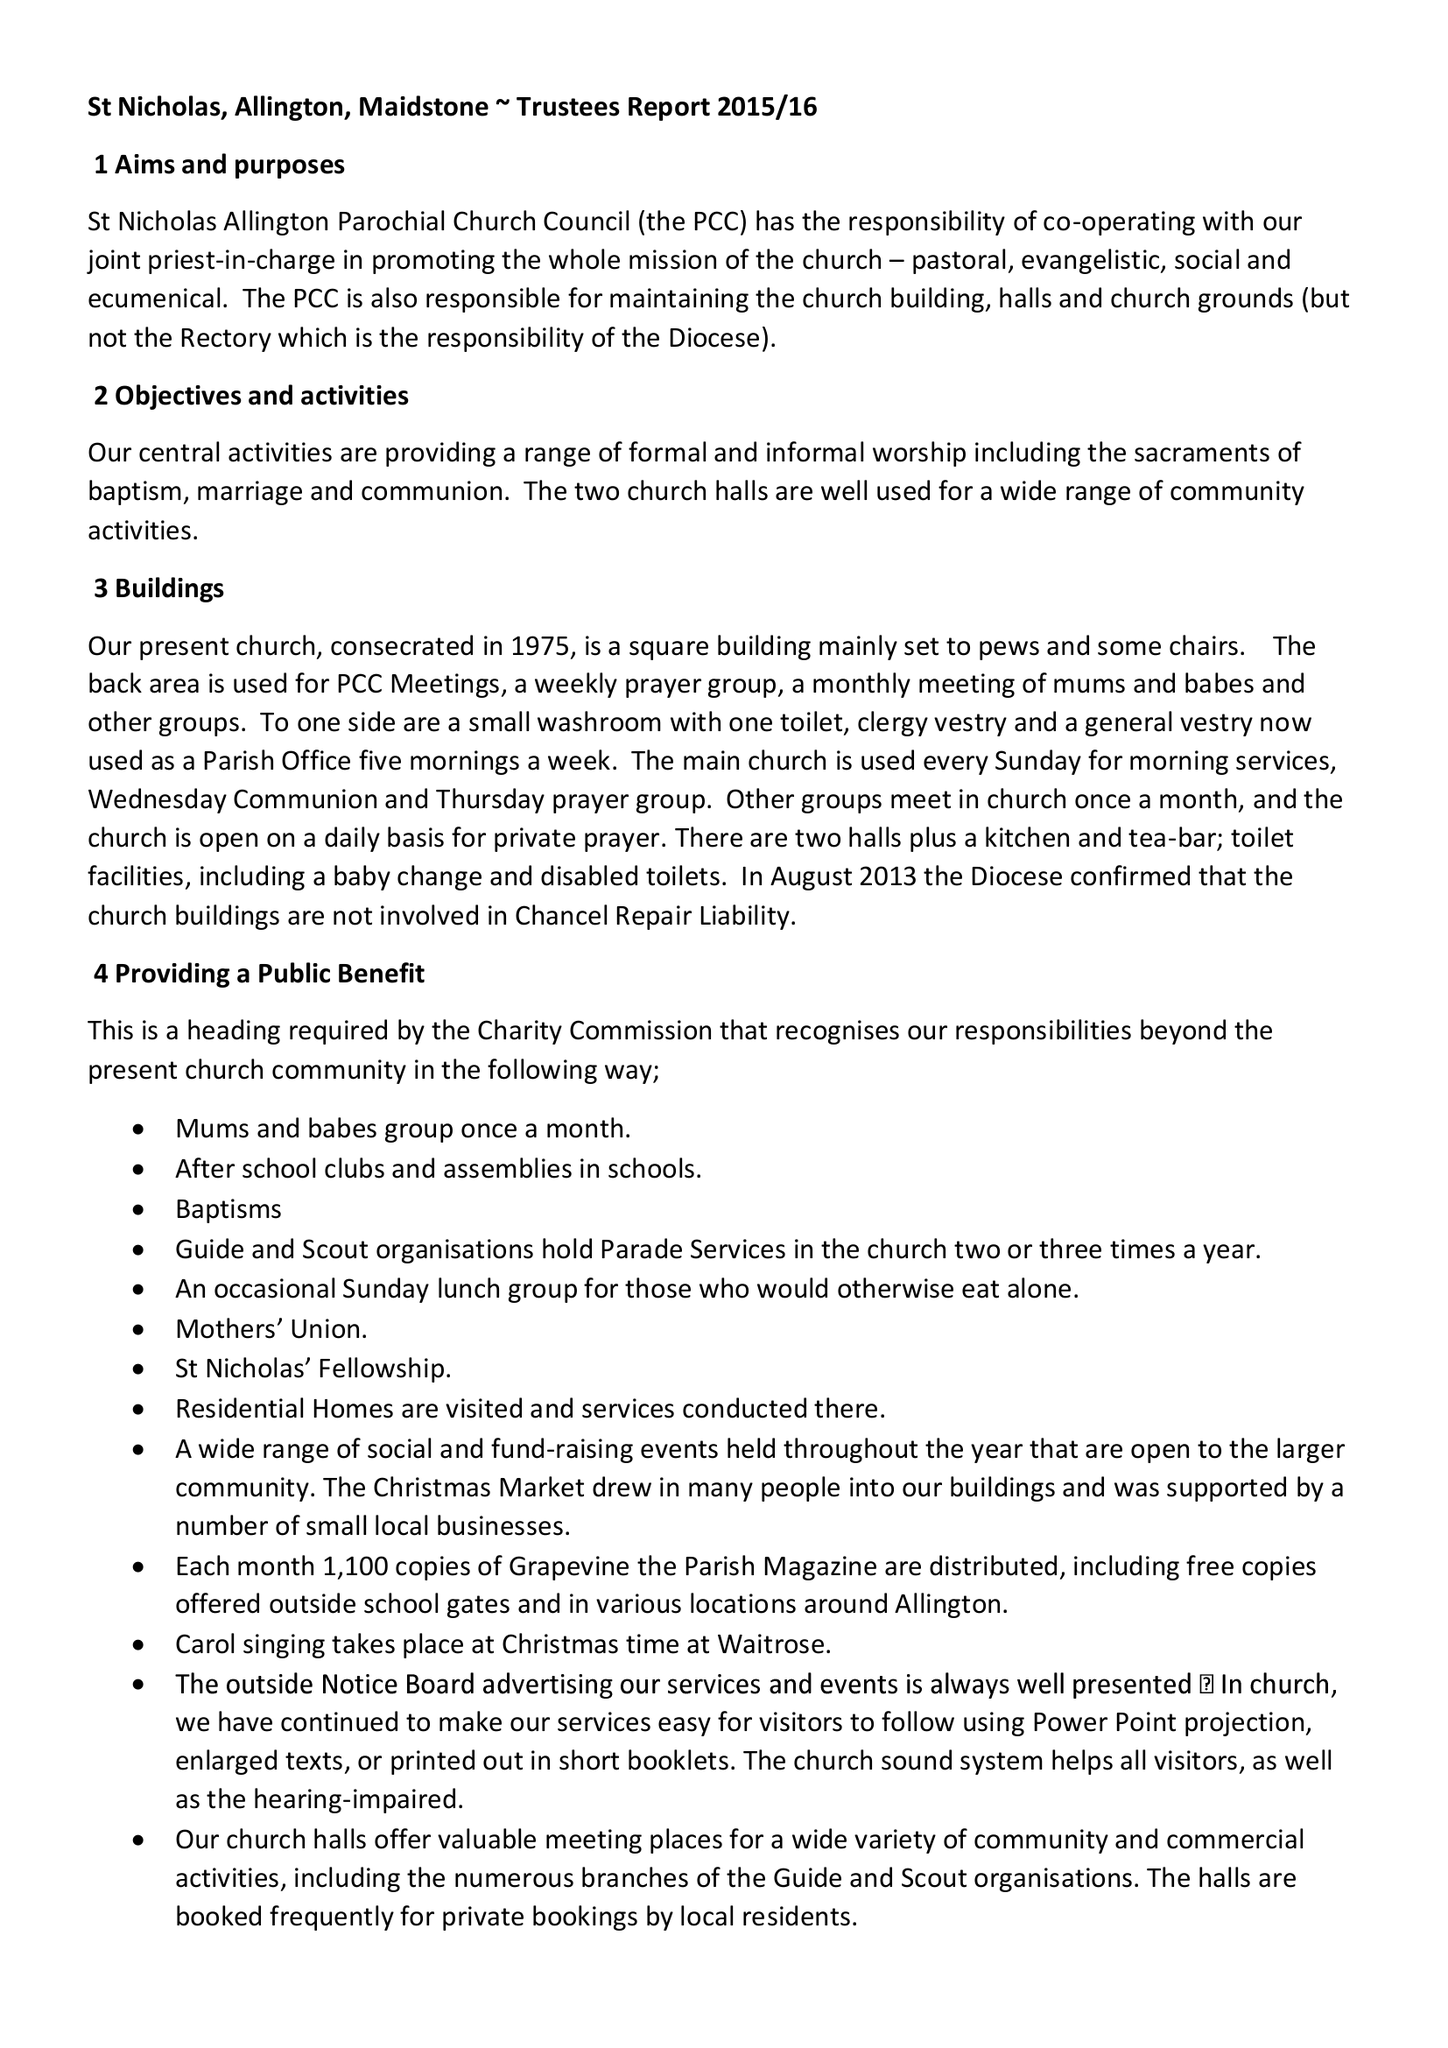What is the value for the address__post_town?
Answer the question using a single word or phrase. MAIDSTONE 